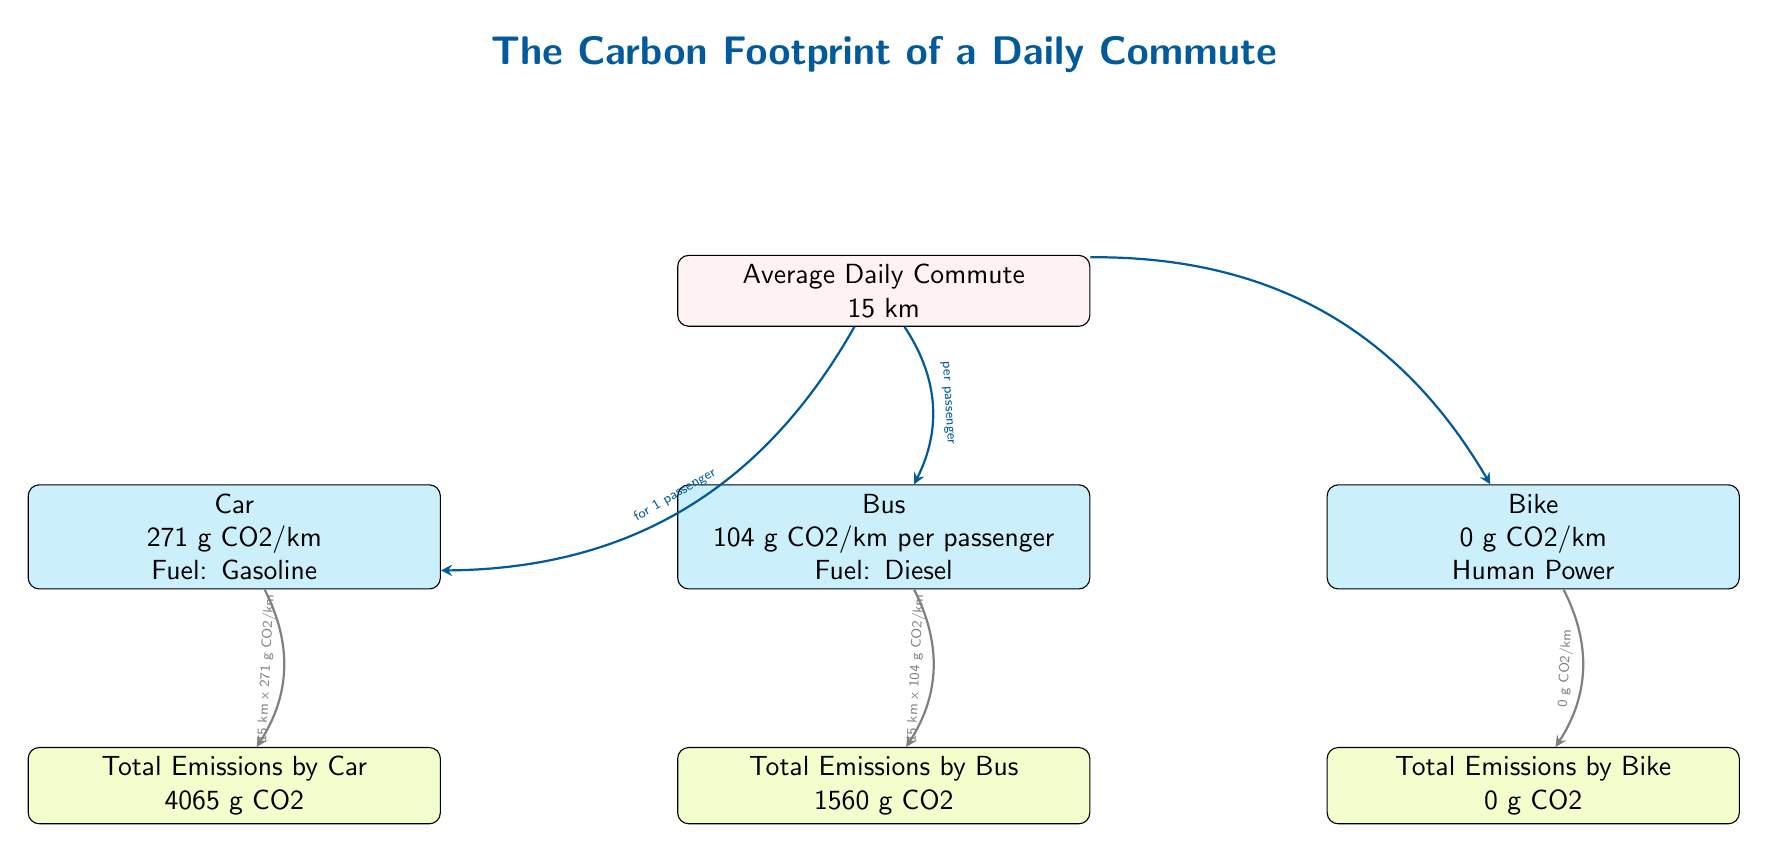What are the emissions from a bus per passenger? The node labeled "Bus" states it emits 104 grams of CO2 per kilometer for each passenger.
Answer: 104 g CO2/km per passenger What is the total emission from commuting by car? The total emissions from the "Car" node indicate that it produces 4065 grams of CO2, which results from 15 km multiplied by 271 g CO2/km.
Answer: 4065 g CO2 Which mode of transportation has zero emissions? The "Bike" node clearly states that it emits 0 grams of CO2 per kilometer, indicating no emissions at all.
Answer: Bike How much CO2 does a bus emit for a 15 km commute? To find this, we multiply the bus emission rate of 104 g CO2/km by the 15 km commute, resulting in 1560 grams of CO2, as shown in the "Total Emissions by Bus" node.
Answer: 1560 g CO2 Which transportation mode has the highest emissions? Comparing the emissions from each mode, the car has the highest emissions with 4065 grams of CO2 per commute, as indicated by the emission nodes.
Answer: Car 